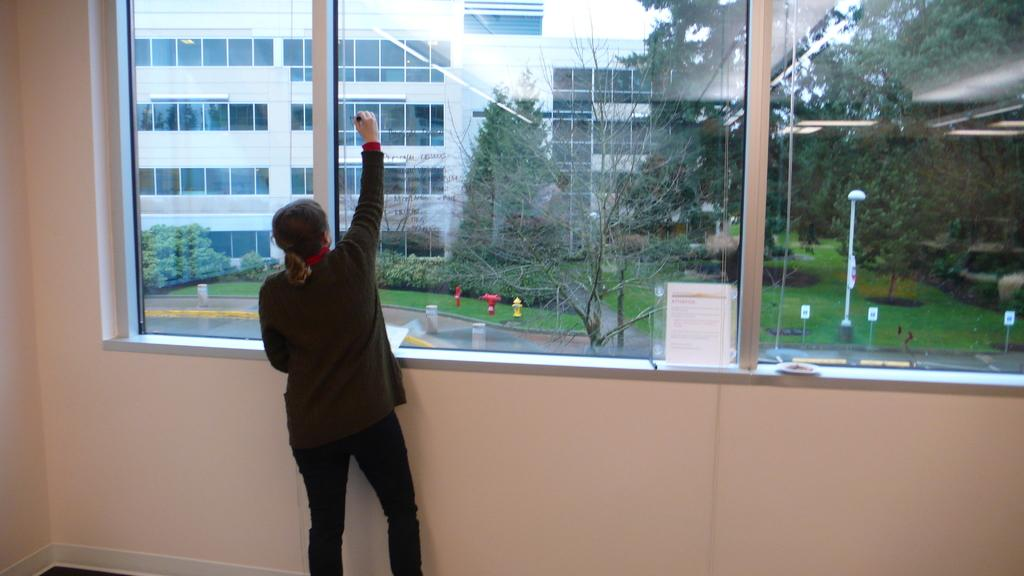What is the lady doing in the image? The lady is standing in the image. What is the purpose of the glass window in the image? The glass window allows for a view of the building, trees, grass, and road. What is located on the left side of the image? There is a wall on the left side of the image. What type of arithmetic problem is the lady solving in the image? There is no indication in the image that the lady is solving an arithmetic problem. How does the lady's skirt contribute to the overall aesthetic of the image? The lady is not wearing a skirt in the image, so this question cannot be answered. 